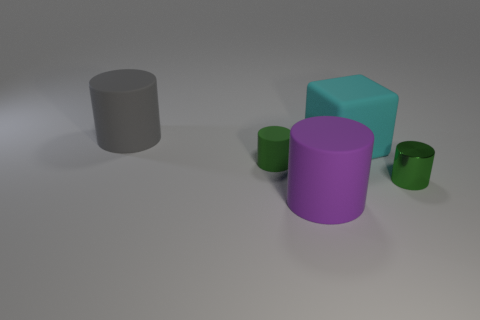Are there any other things that have the same shape as the big cyan matte thing?
Your answer should be compact. No. Are there any large gray cylinders to the right of the large rubber cylinder that is behind the purple rubber object?
Offer a terse response. No. There is a small matte cylinder in front of the cyan matte block; is it the same color as the small thing that is in front of the tiny rubber object?
Offer a terse response. Yes. There is a small matte object; how many small green rubber cylinders are to the left of it?
Your response must be concise. 0. How many other small things are the same color as the tiny rubber thing?
Ensure brevity in your answer.  1. Does the large cylinder on the right side of the large gray cylinder have the same material as the cyan block?
Your response must be concise. Yes. How many objects have the same material as the cyan block?
Ensure brevity in your answer.  3. Are there more big cubes right of the gray rubber cylinder than large blue things?
Keep it short and to the point. Yes. What is the size of the rubber thing that is the same color as the metallic cylinder?
Provide a short and direct response. Small. Is there a green metallic thing of the same shape as the gray thing?
Provide a short and direct response. Yes. 